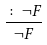<formula> <loc_0><loc_0><loc_500><loc_500>\frac { \colon { \neg } F } { { \neg } F }</formula> 